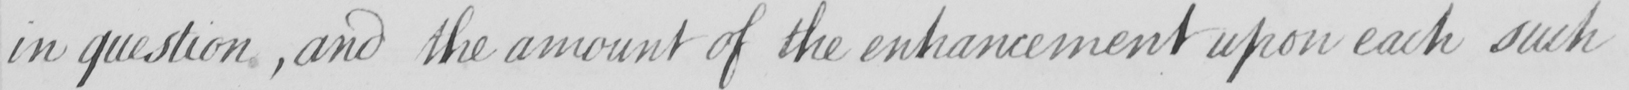What does this handwritten line say? in question  , and the amount of the enhancement upon each such 